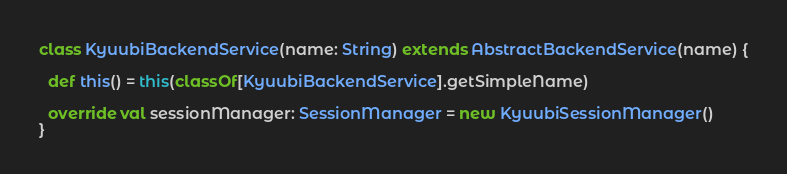Convert code to text. <code><loc_0><loc_0><loc_500><loc_500><_Scala_>class KyuubiBackendService(name: String) extends AbstractBackendService(name) {

  def this() = this(classOf[KyuubiBackendService].getSimpleName)

  override val sessionManager: SessionManager = new KyuubiSessionManager()
}
</code> 